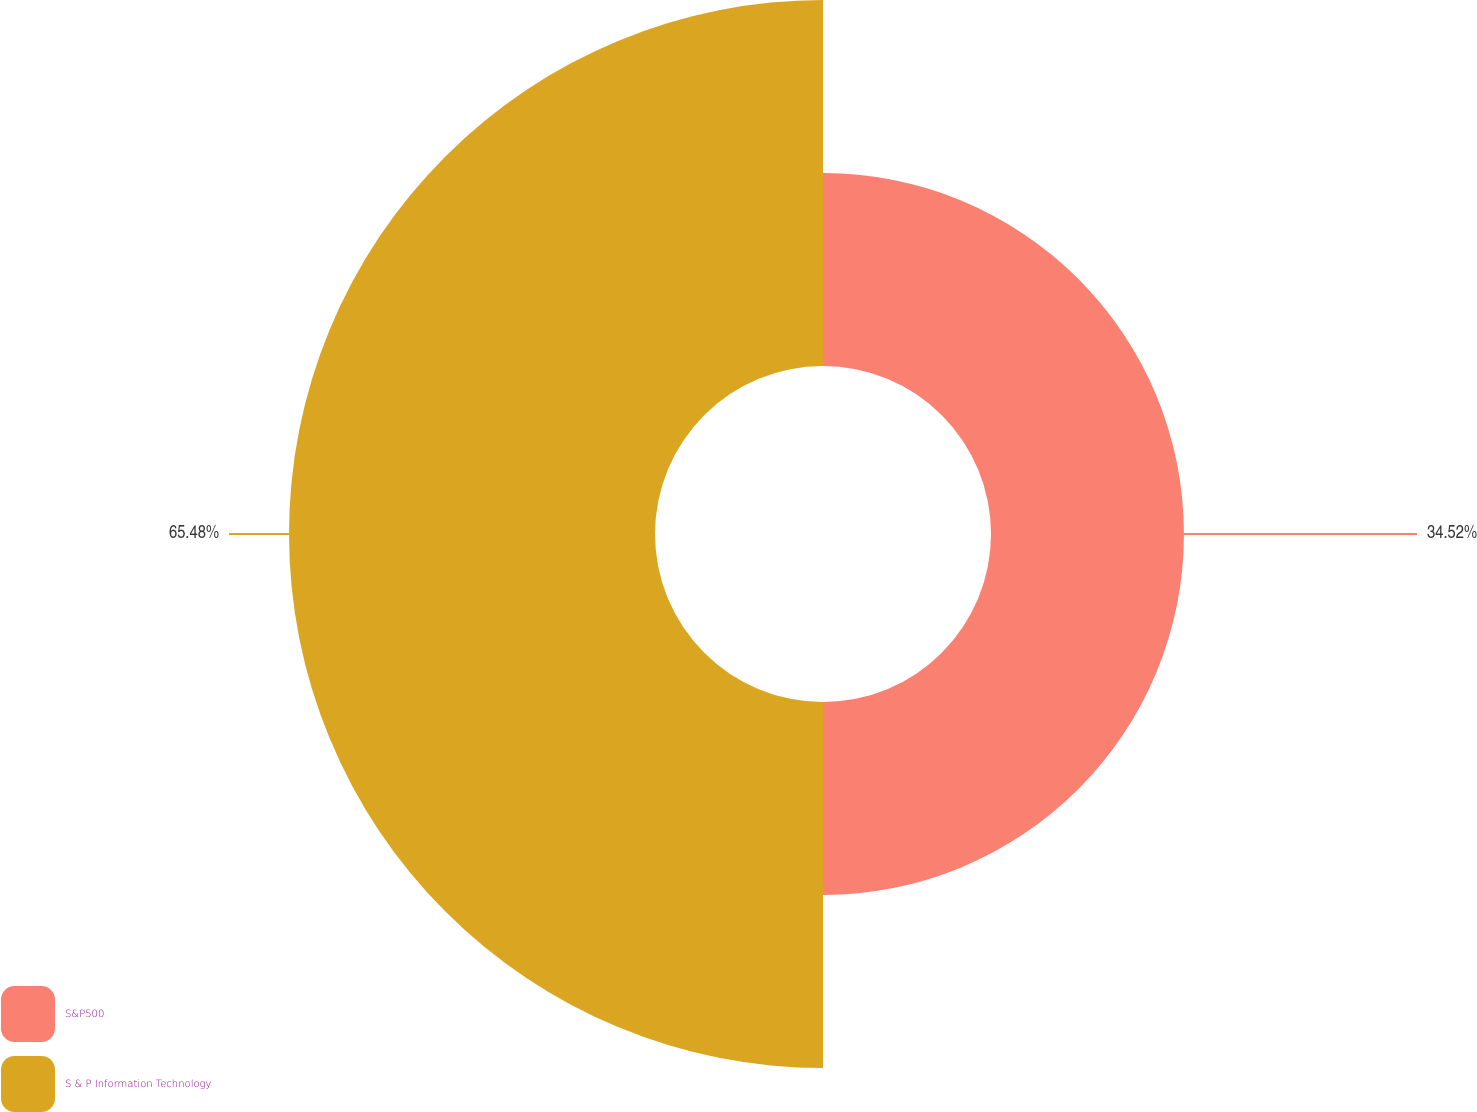Convert chart. <chart><loc_0><loc_0><loc_500><loc_500><pie_chart><fcel>S&P500<fcel>S & P Information Technology<nl><fcel>34.52%<fcel>65.48%<nl></chart> 